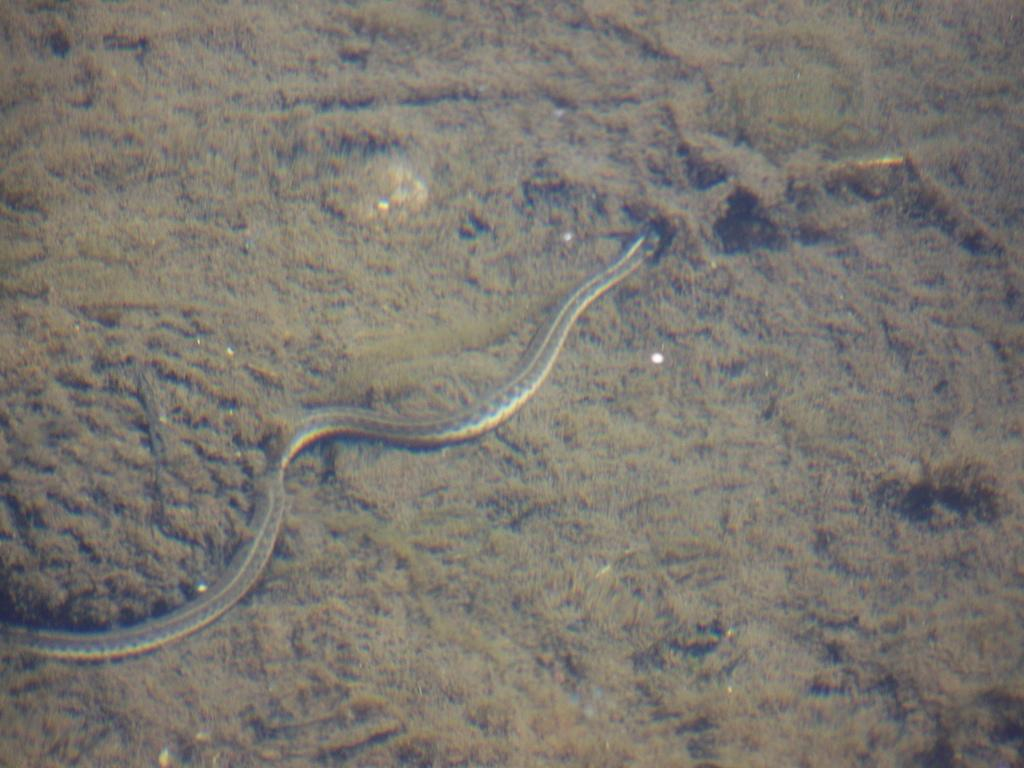What type of animal is in the image? There is a snake in the image. Where is the snake located? The snake is on the ground. What type of treatment is the snake receiving in the image? There is no indication in the image that the snake is receiving any treatment. 